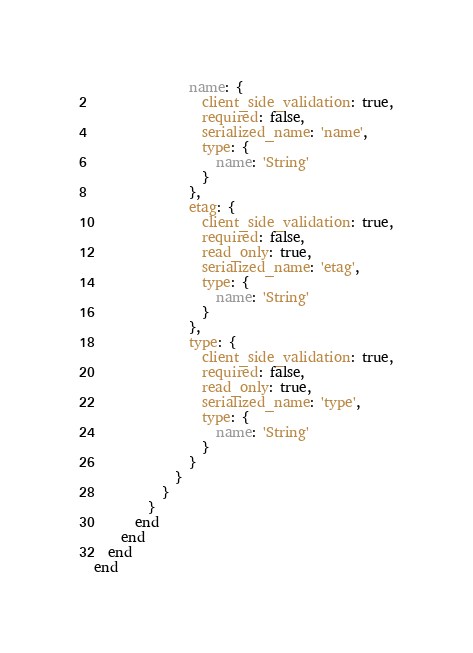Convert code to text. <code><loc_0><loc_0><loc_500><loc_500><_Ruby_>              name: {
                client_side_validation: true,
                required: false,
                serialized_name: 'name',
                type: {
                  name: 'String'
                }
              },
              etag: {
                client_side_validation: true,
                required: false,
                read_only: true,
                serialized_name: 'etag',
                type: {
                  name: 'String'
                }
              },
              type: {
                client_side_validation: true,
                required: false,
                read_only: true,
                serialized_name: 'type',
                type: {
                  name: 'String'
                }
              }
            }
          }
        }
      end
    end
  end
end
</code> 